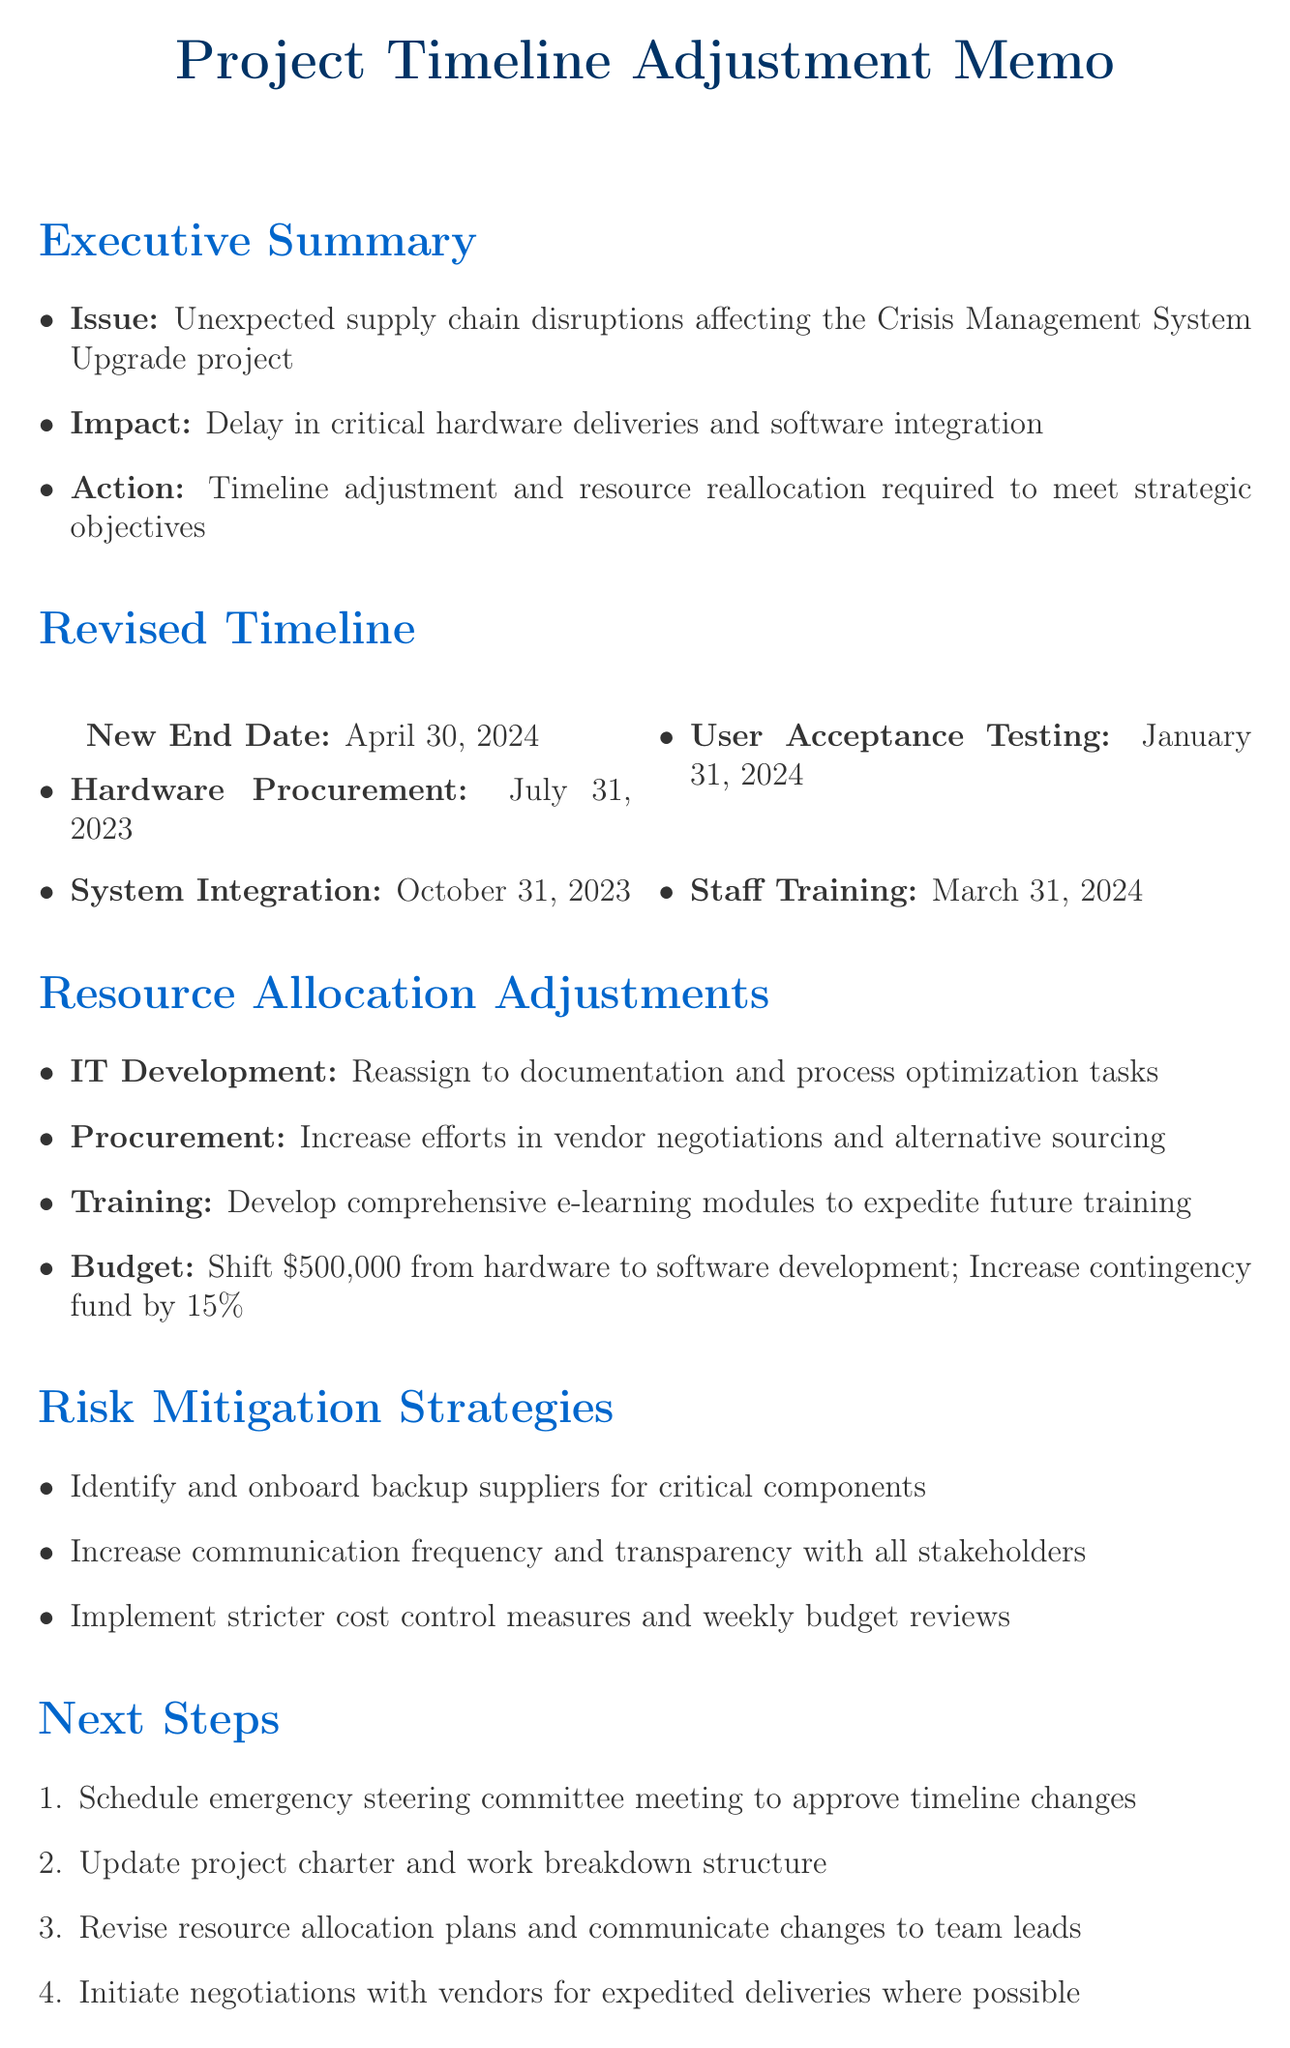what is the original timeline of the project? The original timeline of the Crisis Management System Upgrade project is stated in the background section of the memo.
Answer: January 1, 2023 - December 31, 2023 what is the new end date for the project? The new end date is mentioned in the revised timeline section, indicating when the project will now conclude.
Answer: April 30, 2024 how many months delay is estimated for the supply chain issues? The estimated delay due to supply chain disruptions is provided in the supply chain disruptions section.
Answer: 3-4 months what is one of the primary objectives of the project? A primary objective can be found in the background section, listing the goals of the project.
Answer: Enhance real-time communication capabilities which team is responsible for increasing vendor negotiations? The resource allocation adjustments section specifies which team will increase efforts in vendor negotiations due to the disruptions.
Answer: Procurement what is the allocated budget shift amount? The budget reallocation amount is explicitly stated in the resource allocation adjustments section, detailing how funding is being adjusted.
Answer: $500,000 what is the risk mitigation strategy for stakeholder dissatisfaction? A specific strategy for addressing stakeholder dissatisfaction is included in the risk mitigation strategies section of the memo.
Answer: Increase communication frequency and transparency with all stakeholders which milestone has a revised date of January 31, 2024? The revised timeline section lists milestones with their new dates, including one valued at January 31, 2024.
Answer: User Acceptance Testing how often will project team updates occur? The communication plan outlines the frequency of updates for the project team.
Answer: Weekly status updates 